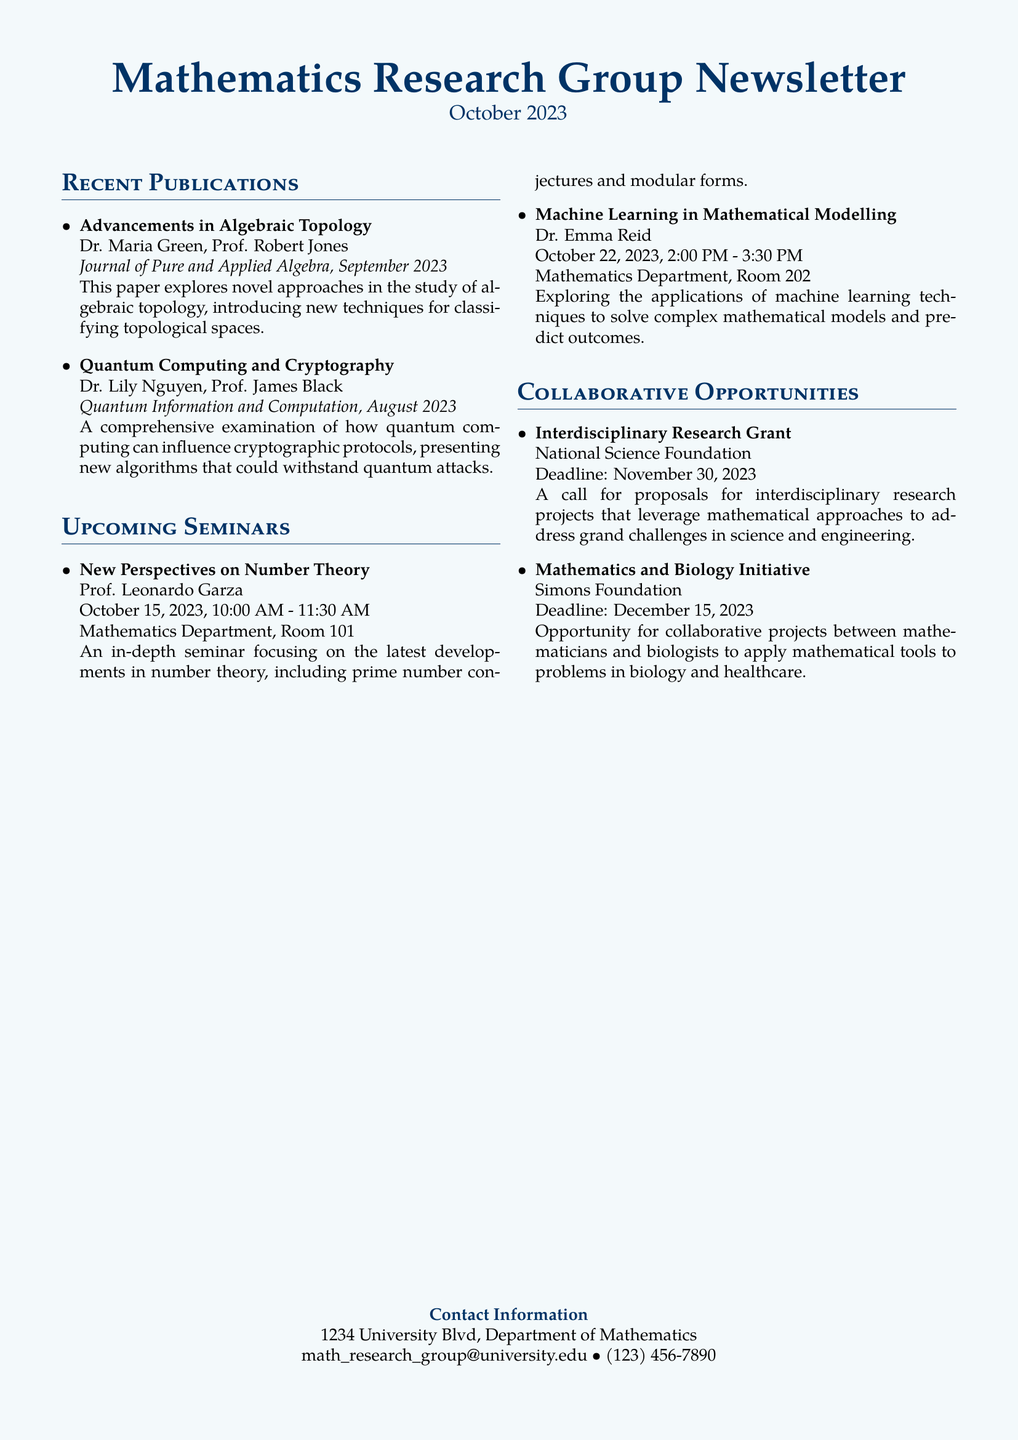What is the title of the newsletter? The title is prominently displayed at the top of the document as the main heading.
Answer: Mathematics Research Group Newsletter When is the seminar on number theory scheduled? The date and time for the seminar are specified under the Upcoming Seminars section.
Answer: October 15, 2023, 10:00 AM - 11:30 AM Who are the authors of the paper on quantum computing? The authors are listed with their names following the title of the publication under Recent Publications.
Answer: Dr. Lily Nguyen, Prof. James Black What is the deadline for the Interdisciplinary Research Grant? The deadline is mentioned in the Collaborations Opportunities section of the document.
Answer: November 30, 2023 Which publication discusses advancements in algebraic topology? The title of the publication is provided in the Recent Publications section.
Answer: Advancements in Algebraic Topology Who is presenting the seminar on machine learning? The speaker's name is listed under the corresponding seminar details in the Upcoming Seminars section.
Answer: Dr. Emma Reid How many publications are listed in the Recent Publications section? The number of publications can be determined by counting the items listed.
Answer: 2 What is the focus of the Mathematics and Biology Initiative? The initiative's purpose is described in the Collaborations Opportunities section.
Answer: Collaborative projects between mathematicians and biologists 